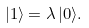<formula> <loc_0><loc_0><loc_500><loc_500>| 1 \rangle = \lambda \, | 0 \rangle .</formula> 